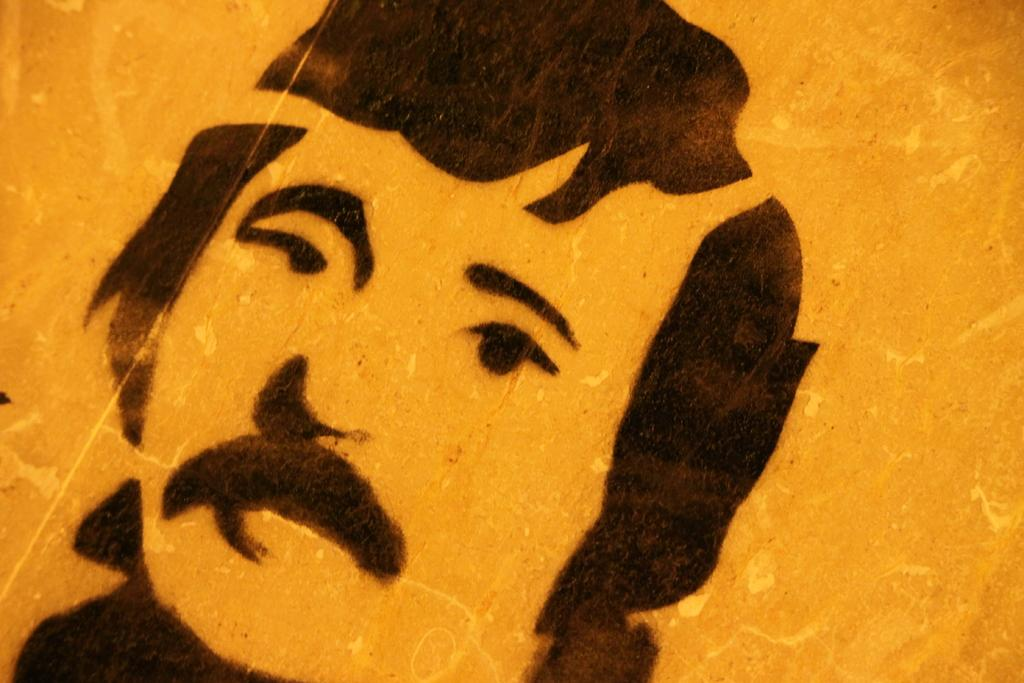What is the main subject of the image? There is an art piece in the image. What does the art piece depict? The art piece depicts a person's face. What type of muscle is visible in the art piece? There is no muscle visible in the art piece, as it depicts a person's face and not a body part. 